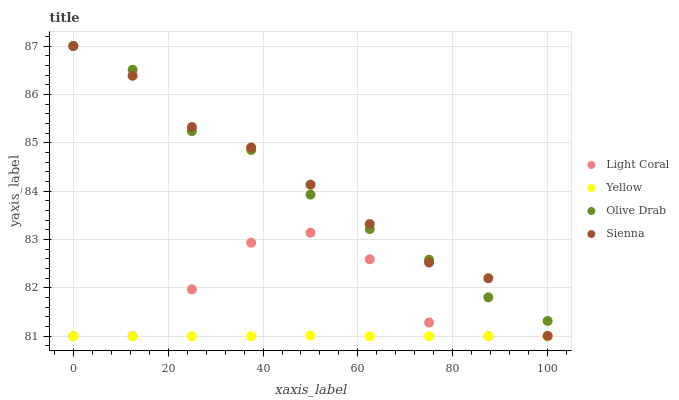Does Yellow have the minimum area under the curve?
Answer yes or no. Yes. Does Sienna have the maximum area under the curve?
Answer yes or no. Yes. Does Olive Drab have the minimum area under the curve?
Answer yes or no. No. Does Olive Drab have the maximum area under the curve?
Answer yes or no. No. Is Yellow the smoothest?
Answer yes or no. Yes. Is Light Coral the roughest?
Answer yes or no. Yes. Is Sienna the smoothest?
Answer yes or no. No. Is Sienna the roughest?
Answer yes or no. No. Does Light Coral have the lowest value?
Answer yes or no. Yes. Does Sienna have the lowest value?
Answer yes or no. No. Does Olive Drab have the highest value?
Answer yes or no. Yes. Does Yellow have the highest value?
Answer yes or no. No. Is Yellow less than Sienna?
Answer yes or no. Yes. Is Olive Drab greater than Yellow?
Answer yes or no. Yes. Does Sienna intersect Olive Drab?
Answer yes or no. Yes. Is Sienna less than Olive Drab?
Answer yes or no. No. Is Sienna greater than Olive Drab?
Answer yes or no. No. Does Yellow intersect Sienna?
Answer yes or no. No. 